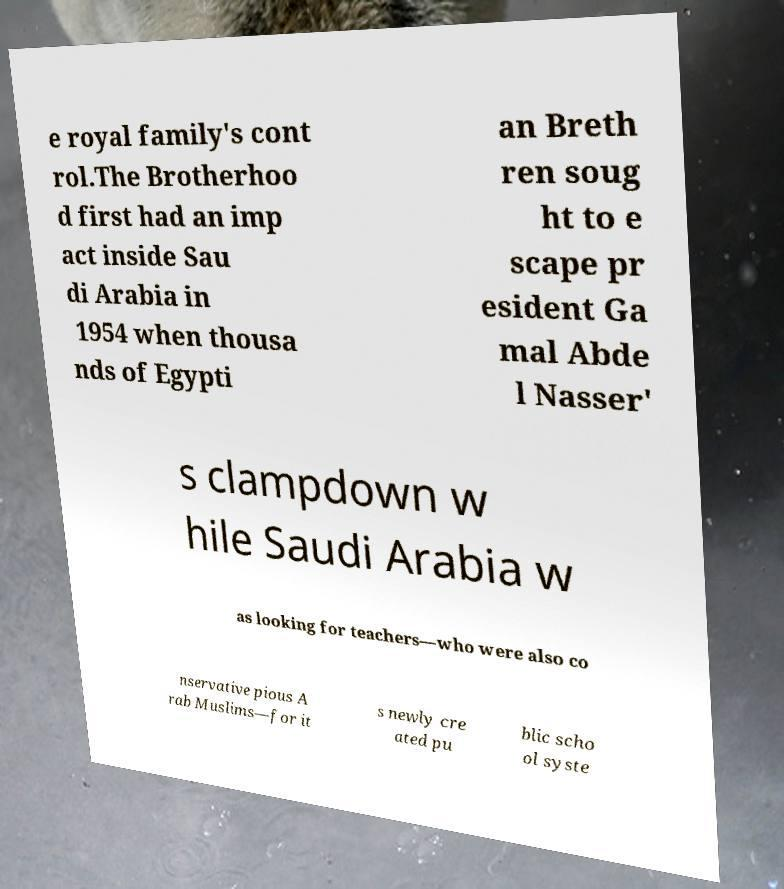Could you extract and type out the text from this image? e royal family's cont rol.The Brotherhoo d first had an imp act inside Sau di Arabia in 1954 when thousa nds of Egypti an Breth ren soug ht to e scape pr esident Ga mal Abde l Nasser' s clampdown w hile Saudi Arabia w as looking for teachers—who were also co nservative pious A rab Muslims—for it s newly cre ated pu blic scho ol syste 